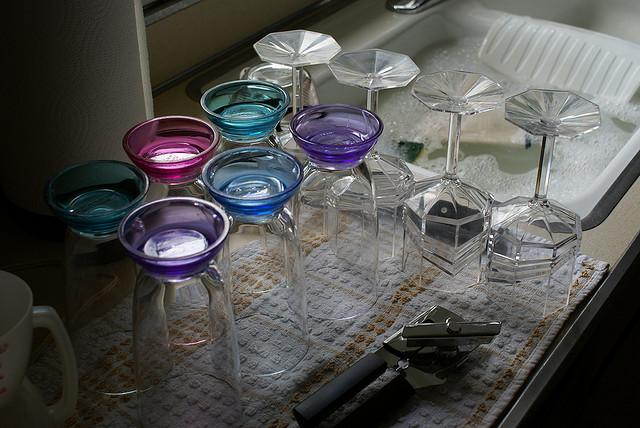Why are the glasses on a rag next to the sink?

Choices:
A) to sell
B) for dinner
C) storage
D) just washed just washed 